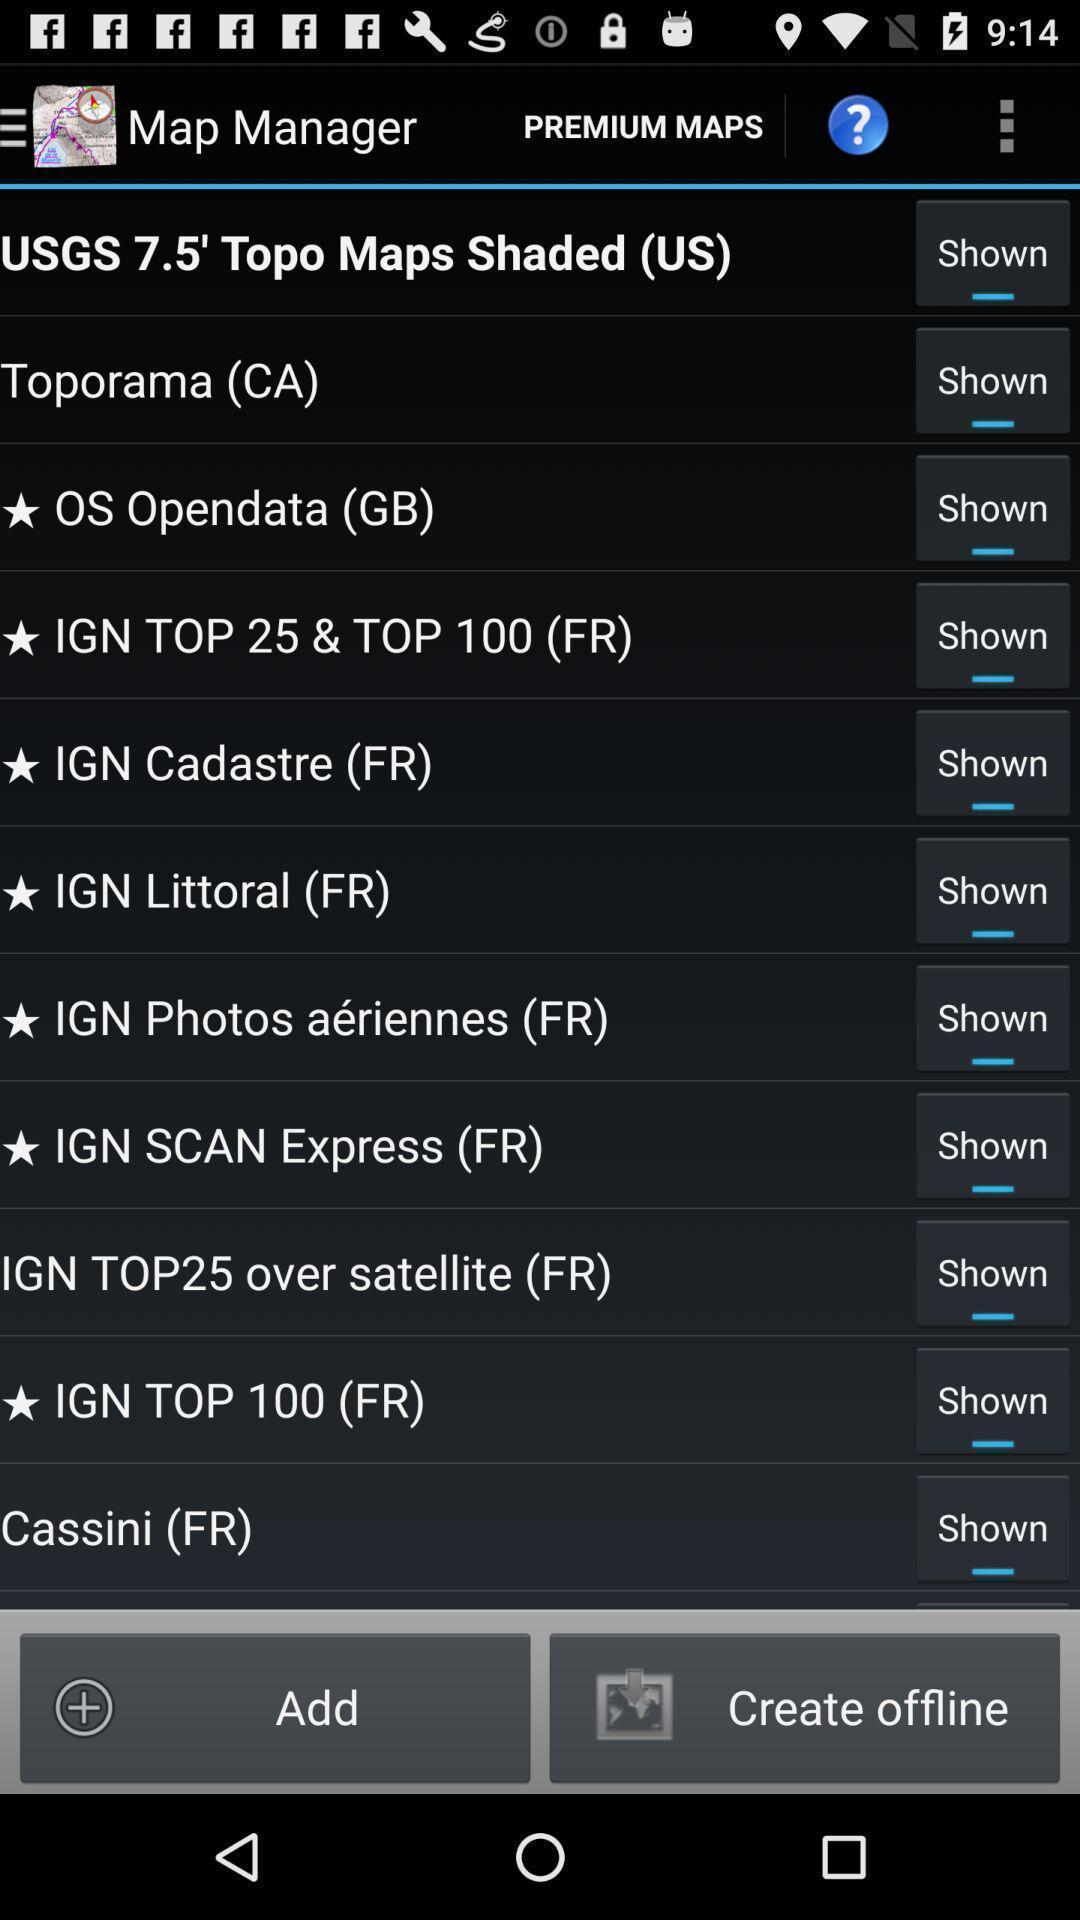Describe the content in this image. Page displays to add a file in app. 